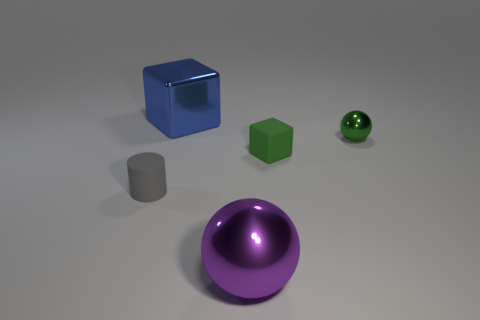How many other objects are the same material as the large blue block?
Your answer should be very brief. 2. There is a metal thing in front of the green shiny object; how big is it?
Give a very brief answer. Large. What number of objects are both left of the purple shiny thing and to the right of the small matte cylinder?
Make the answer very short. 1. The tiny thing to the left of the big thing that is behind the big metal sphere is made of what material?
Keep it short and to the point. Rubber. What is the material of the tiny object that is the same shape as the big blue thing?
Provide a succinct answer. Rubber. Are any big things visible?
Your answer should be compact. Yes. What shape is the small thing that is made of the same material as the large block?
Your answer should be compact. Sphere. What is the material of the big thing that is on the right side of the large block?
Offer a terse response. Metal. Is the color of the metal thing that is right of the purple sphere the same as the metallic cube?
Provide a succinct answer. No. There is a ball that is right of the large thing right of the blue block; what size is it?
Ensure brevity in your answer.  Small. 